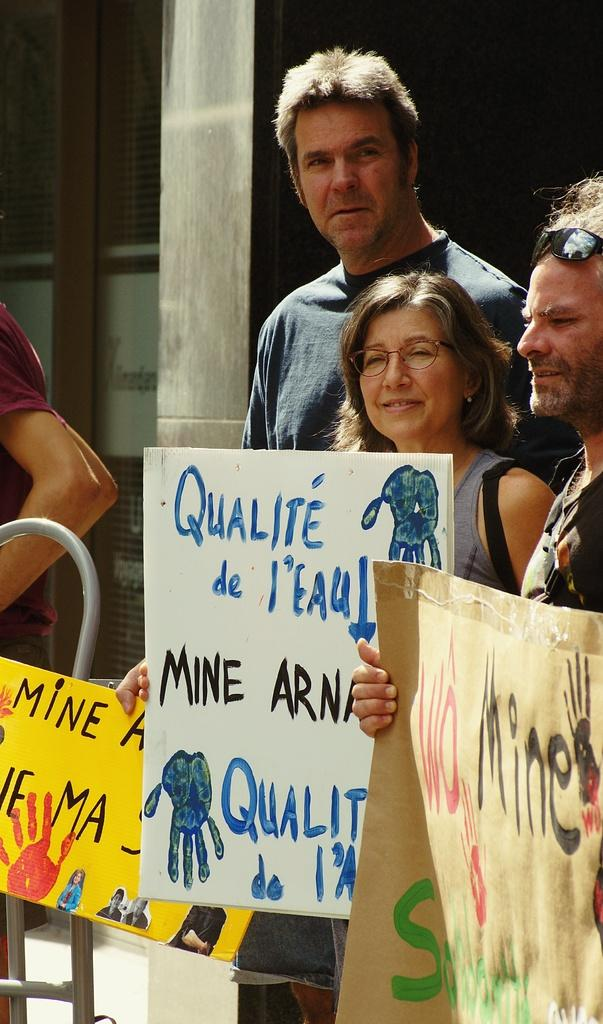How many people are present in the image? There are four people in the image. What are some of the people holding in the image? Three of the people are holding posters. Can you describe the eyewear of any of the people in the image? At least one person is wearing spectacles, and at least one person is wearing goggles. What can be seen in the background of the image? There is a pillar and windows in the background of the image. What type of crayon is being used by the person in the image? There is no crayon present in the image. How does the person's temper affect their ability to hold the poster in the image? There is no indication of the person's temper in the image, and it does not affect their ability to hold the poster. 